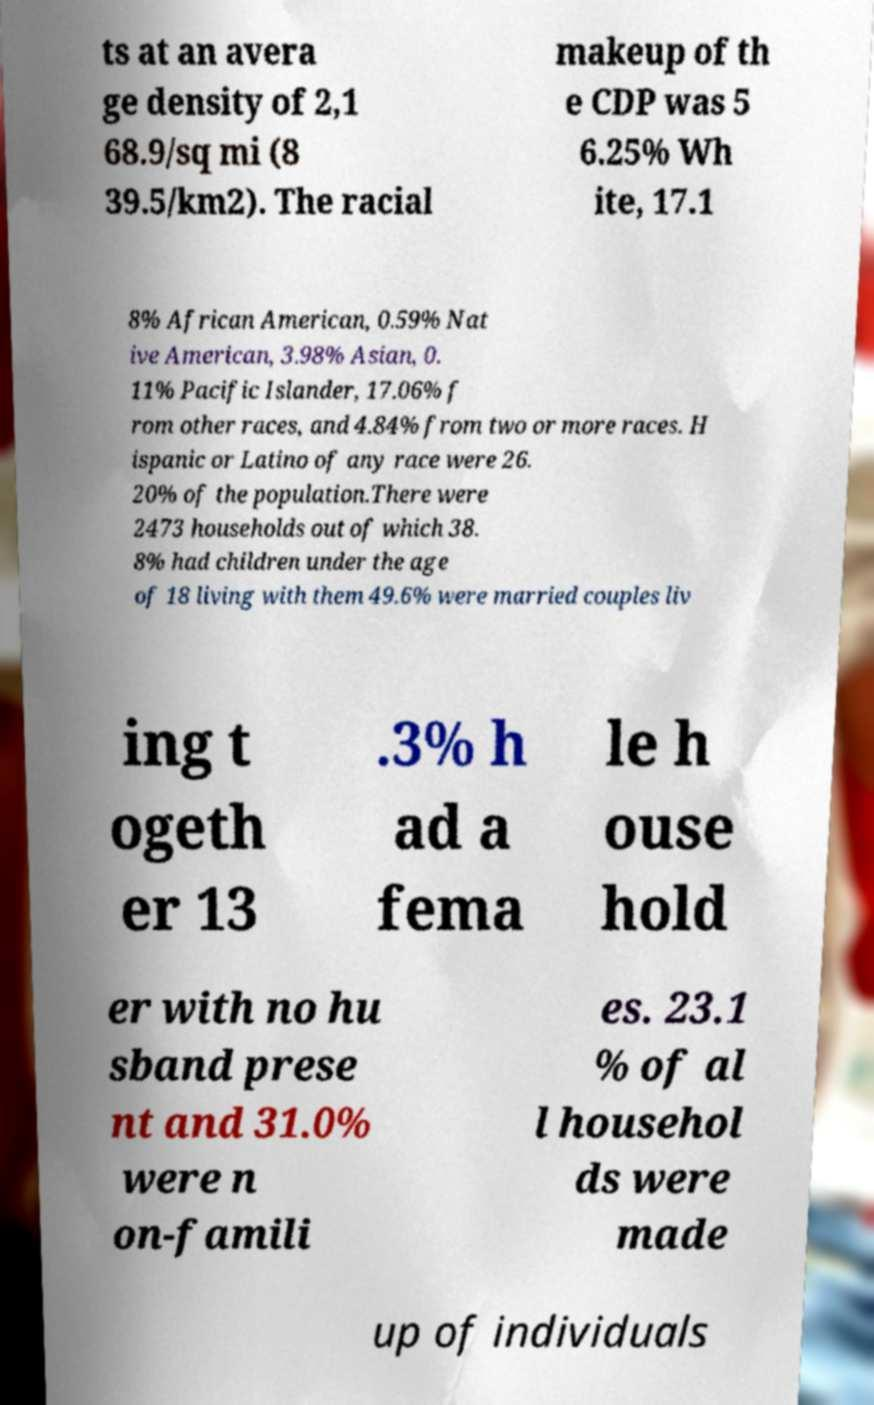Please identify and transcribe the text found in this image. ts at an avera ge density of 2,1 68.9/sq mi (8 39.5/km2). The racial makeup of th e CDP was 5 6.25% Wh ite, 17.1 8% African American, 0.59% Nat ive American, 3.98% Asian, 0. 11% Pacific Islander, 17.06% f rom other races, and 4.84% from two or more races. H ispanic or Latino of any race were 26. 20% of the population.There were 2473 households out of which 38. 8% had children under the age of 18 living with them 49.6% were married couples liv ing t ogeth er 13 .3% h ad a fema le h ouse hold er with no hu sband prese nt and 31.0% were n on-famili es. 23.1 % of al l househol ds were made up of individuals 